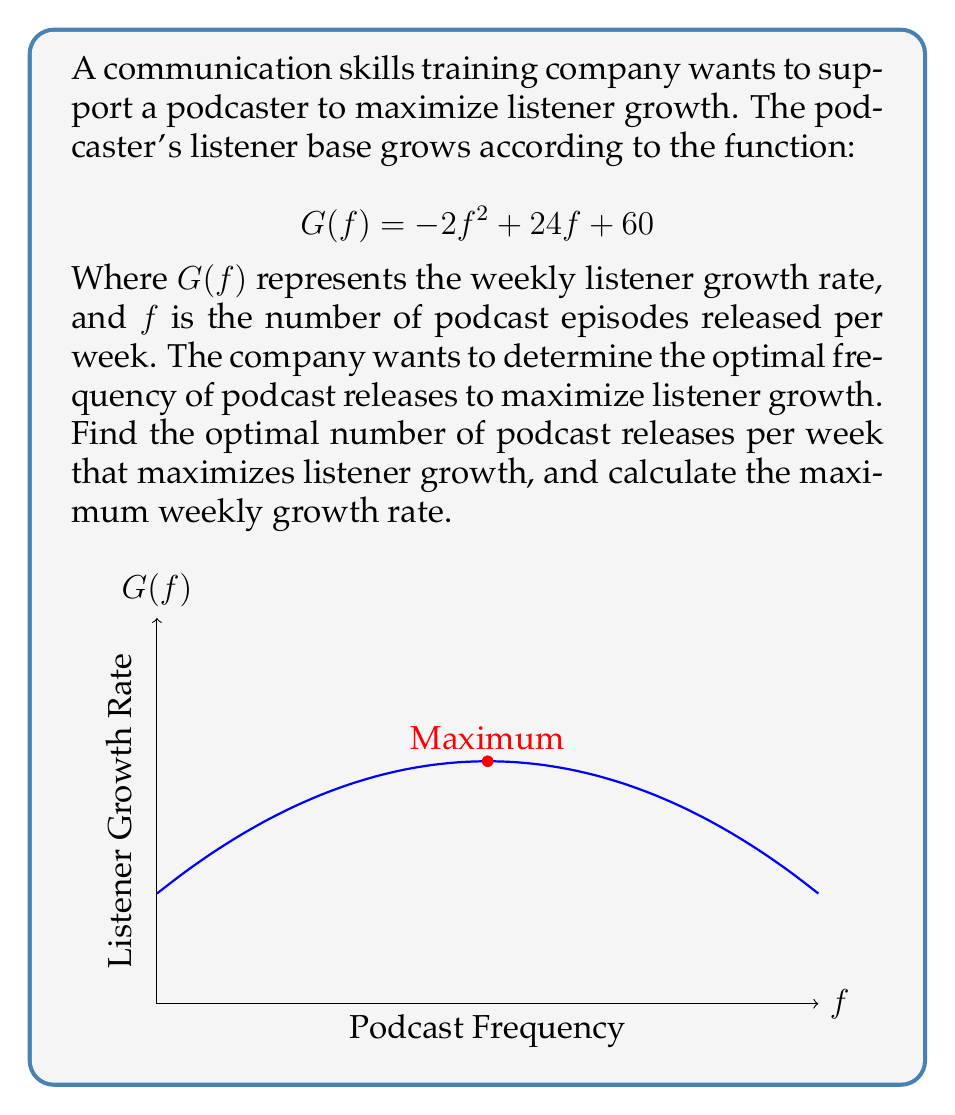Can you solve this math problem? To find the optimal frequency of podcast releases, we need to maximize the function $G(f) = -2f^2 + 24f + 60$. This is a quadratic function, and its graph is a parabola that opens downward due to the negative coefficient of $f^2$.

Step 1: Find the vertex of the parabola.
For a quadratic function in the form $ax^2 + bx + c$, the x-coordinate of the vertex is given by $x = -\frac{b}{2a}$.

In this case, $a = -2$, $b = 24$, and $c = 60$.

$f = -\frac{b}{2a} = -\frac{24}{2(-2)} = \frac{24}{4} = 6$

Step 2: Verify that this is a maximum.
Since the parabola opens downward (coefficient of $f^2$ is negative), the vertex represents a maximum point.

Step 3: Calculate the maximum growth rate.
Substitute $f = 6$ into the original function:

$G(6) = -2(6)^2 + 24(6) + 60$
$= -2(36) + 144 + 60$
$= -72 + 144 + 60$
$= 132$

Therefore, the optimal frequency is 6 podcast releases per week, which results in a maximum weekly listener growth rate of 132.
Answer: 6 releases/week; 132 listeners/week 